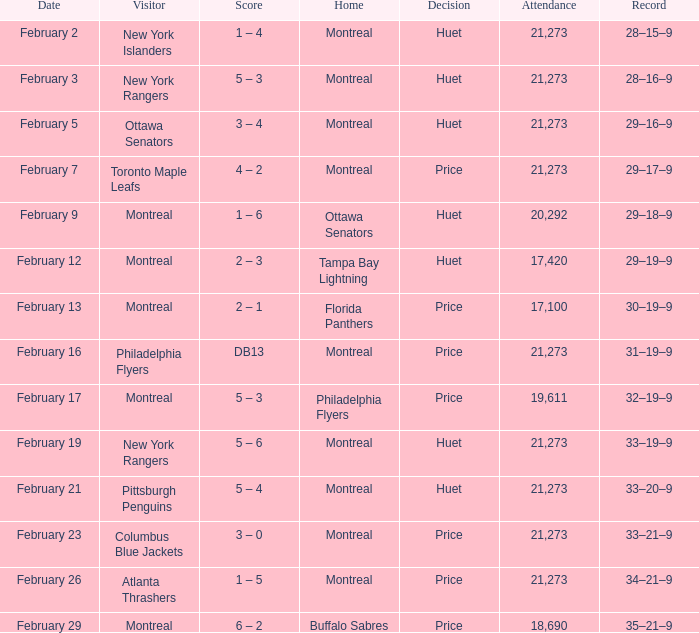At the game where the canadiens held a 30-19-9 record, who was the guest team? Montreal. 